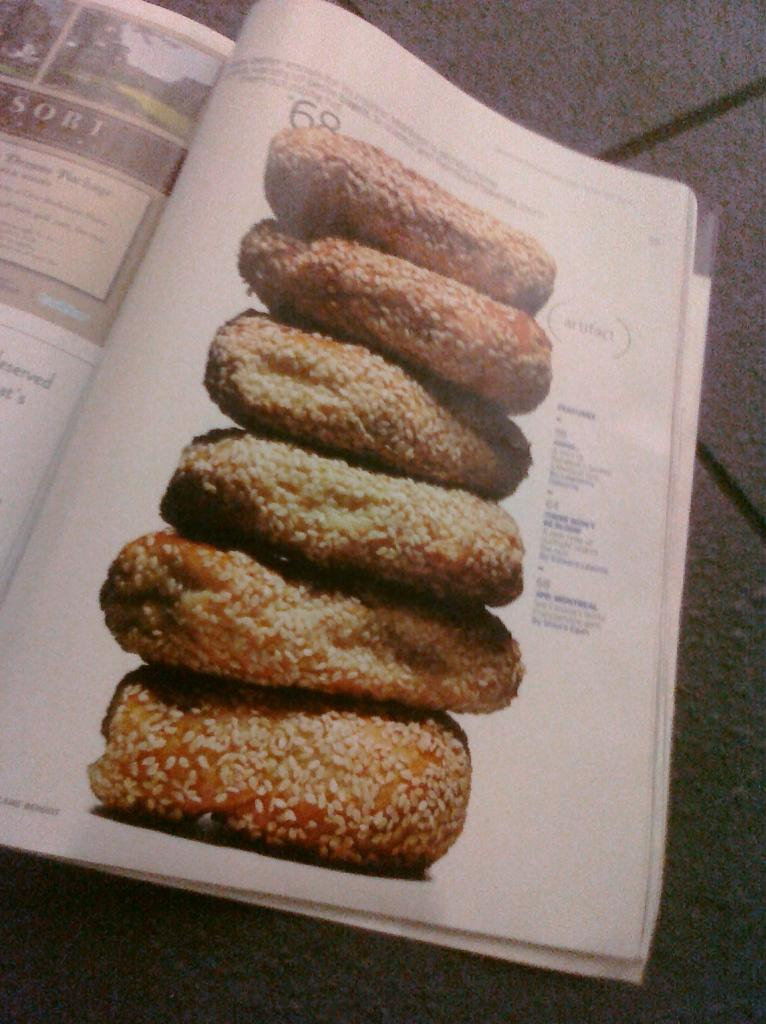What is present on the floor in the image? There is a book on the floor in the image. What type of content does the book contain? The book contains both images and text. What is the price of the book in the image? The price of the book is not visible in the image, so it cannot be determined. 